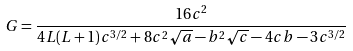<formula> <loc_0><loc_0><loc_500><loc_500>G = \frac { 1 6 c ^ { 2 } } { 4 L ( L + 1 ) c ^ { 3 / 2 } + 8 c ^ { 2 } \sqrt { a } - b ^ { 2 } \sqrt { c } - 4 c b - 3 c ^ { 3 / 2 } }</formula> 